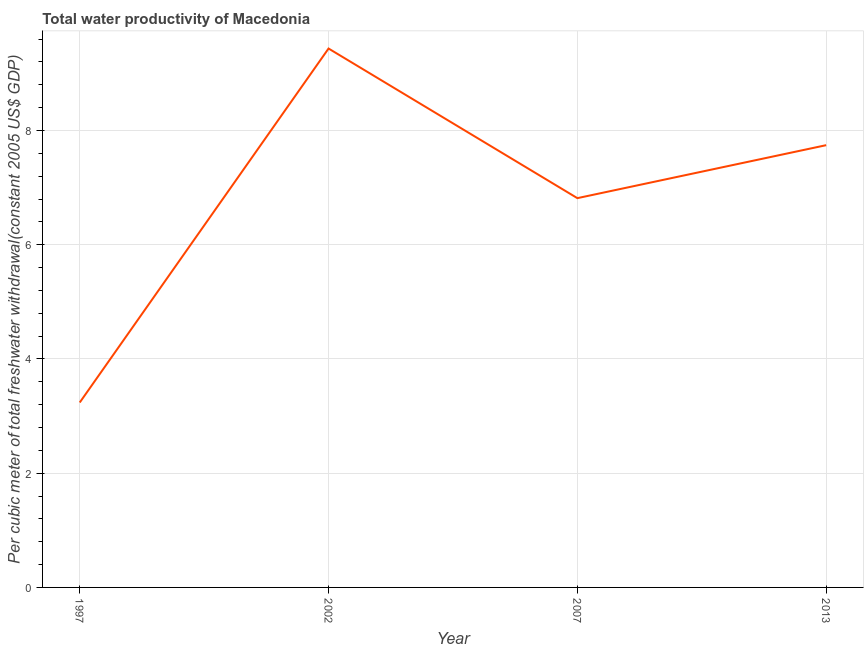What is the total water productivity in 1997?
Provide a succinct answer. 3.24. Across all years, what is the maximum total water productivity?
Offer a terse response. 9.43. Across all years, what is the minimum total water productivity?
Ensure brevity in your answer.  3.24. In which year was the total water productivity maximum?
Offer a terse response. 2002. What is the sum of the total water productivity?
Ensure brevity in your answer.  27.23. What is the difference between the total water productivity in 1997 and 2002?
Your answer should be very brief. -6.2. What is the average total water productivity per year?
Give a very brief answer. 6.81. What is the median total water productivity?
Provide a succinct answer. 7.28. What is the ratio of the total water productivity in 1997 to that in 2007?
Offer a terse response. 0.48. Is the difference between the total water productivity in 2002 and 2013 greater than the difference between any two years?
Provide a succinct answer. No. What is the difference between the highest and the second highest total water productivity?
Offer a very short reply. 1.69. What is the difference between the highest and the lowest total water productivity?
Your response must be concise. 6.2. How many years are there in the graph?
Your response must be concise. 4. Are the values on the major ticks of Y-axis written in scientific E-notation?
Provide a short and direct response. No. Does the graph contain grids?
Your answer should be very brief. Yes. What is the title of the graph?
Offer a terse response. Total water productivity of Macedonia. What is the label or title of the X-axis?
Give a very brief answer. Year. What is the label or title of the Y-axis?
Your answer should be very brief. Per cubic meter of total freshwater withdrawal(constant 2005 US$ GDP). What is the Per cubic meter of total freshwater withdrawal(constant 2005 US$ GDP) in 1997?
Keep it short and to the point. 3.24. What is the Per cubic meter of total freshwater withdrawal(constant 2005 US$ GDP) of 2002?
Keep it short and to the point. 9.43. What is the Per cubic meter of total freshwater withdrawal(constant 2005 US$ GDP) in 2007?
Provide a succinct answer. 6.82. What is the Per cubic meter of total freshwater withdrawal(constant 2005 US$ GDP) in 2013?
Offer a terse response. 7.74. What is the difference between the Per cubic meter of total freshwater withdrawal(constant 2005 US$ GDP) in 1997 and 2002?
Provide a short and direct response. -6.2. What is the difference between the Per cubic meter of total freshwater withdrawal(constant 2005 US$ GDP) in 1997 and 2007?
Provide a succinct answer. -3.58. What is the difference between the Per cubic meter of total freshwater withdrawal(constant 2005 US$ GDP) in 1997 and 2013?
Ensure brevity in your answer.  -4.51. What is the difference between the Per cubic meter of total freshwater withdrawal(constant 2005 US$ GDP) in 2002 and 2007?
Ensure brevity in your answer.  2.62. What is the difference between the Per cubic meter of total freshwater withdrawal(constant 2005 US$ GDP) in 2002 and 2013?
Provide a short and direct response. 1.69. What is the difference between the Per cubic meter of total freshwater withdrawal(constant 2005 US$ GDP) in 2007 and 2013?
Your response must be concise. -0.93. What is the ratio of the Per cubic meter of total freshwater withdrawal(constant 2005 US$ GDP) in 1997 to that in 2002?
Keep it short and to the point. 0.34. What is the ratio of the Per cubic meter of total freshwater withdrawal(constant 2005 US$ GDP) in 1997 to that in 2007?
Make the answer very short. 0.47. What is the ratio of the Per cubic meter of total freshwater withdrawal(constant 2005 US$ GDP) in 1997 to that in 2013?
Your answer should be compact. 0.42. What is the ratio of the Per cubic meter of total freshwater withdrawal(constant 2005 US$ GDP) in 2002 to that in 2007?
Your answer should be compact. 1.38. What is the ratio of the Per cubic meter of total freshwater withdrawal(constant 2005 US$ GDP) in 2002 to that in 2013?
Make the answer very short. 1.22. 